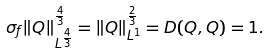Convert formula to latex. <formula><loc_0><loc_0><loc_500><loc_500>\sigma _ { f } \| Q \| _ { L ^ { \frac { 4 } { 3 } } } ^ { \frac { 4 } { 3 } } = \| Q \| _ { L ^ { 1 } } ^ { \frac { 2 } { 3 } } = D ( Q , Q ) = 1 .</formula> 